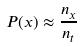Convert formula to latex. <formula><loc_0><loc_0><loc_500><loc_500>P ( x ) \approx \frac { n _ { x } } { n _ { t } }</formula> 